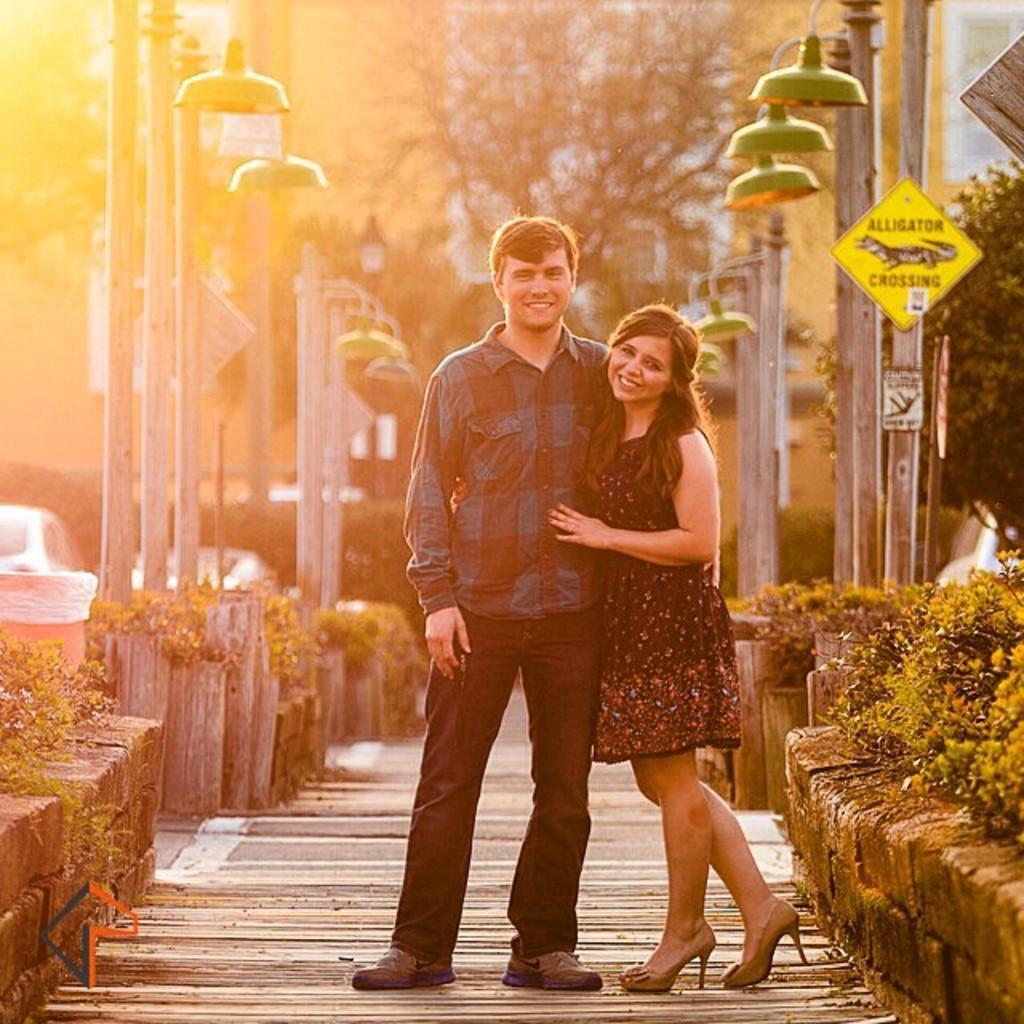Please provide a concise description of this image. In this image I can see two people standing. These people are wearing the different color dresses. To the side of these people I can see plants and many light poles. I can also see the board to the right. In the background there are many trees. And to the left I can see the vehicles. 